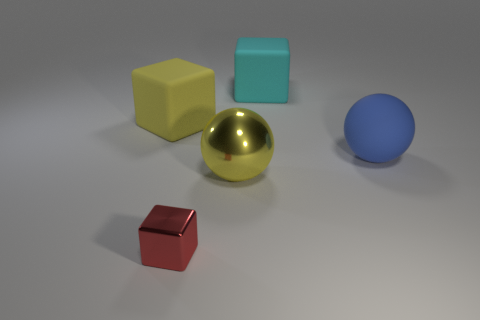What is the size of the yellow thing that is in front of the big rubber thing in front of the big yellow rubber thing?
Give a very brief answer. Large. Are there an equal number of big matte objects on the right side of the large cyan block and metallic spheres on the left side of the small red metallic object?
Give a very brief answer. No. Is there any other thing that is the same size as the yellow rubber object?
Provide a succinct answer. Yes. There is a small block that is the same material as the yellow ball; what is its color?
Your response must be concise. Red. Is the yellow ball made of the same material as the cube that is in front of the large blue rubber ball?
Provide a succinct answer. Yes. The thing that is both to the right of the tiny block and in front of the large blue matte sphere is what color?
Provide a succinct answer. Yellow. What number of cubes are yellow rubber objects or large red shiny things?
Provide a succinct answer. 1. There is a blue object; is its shape the same as the large matte object left of the large metallic thing?
Give a very brief answer. No. There is a object that is both in front of the big yellow rubber block and left of the big shiny thing; what is its size?
Ensure brevity in your answer.  Small. What shape is the yellow metal thing?
Provide a short and direct response. Sphere. 